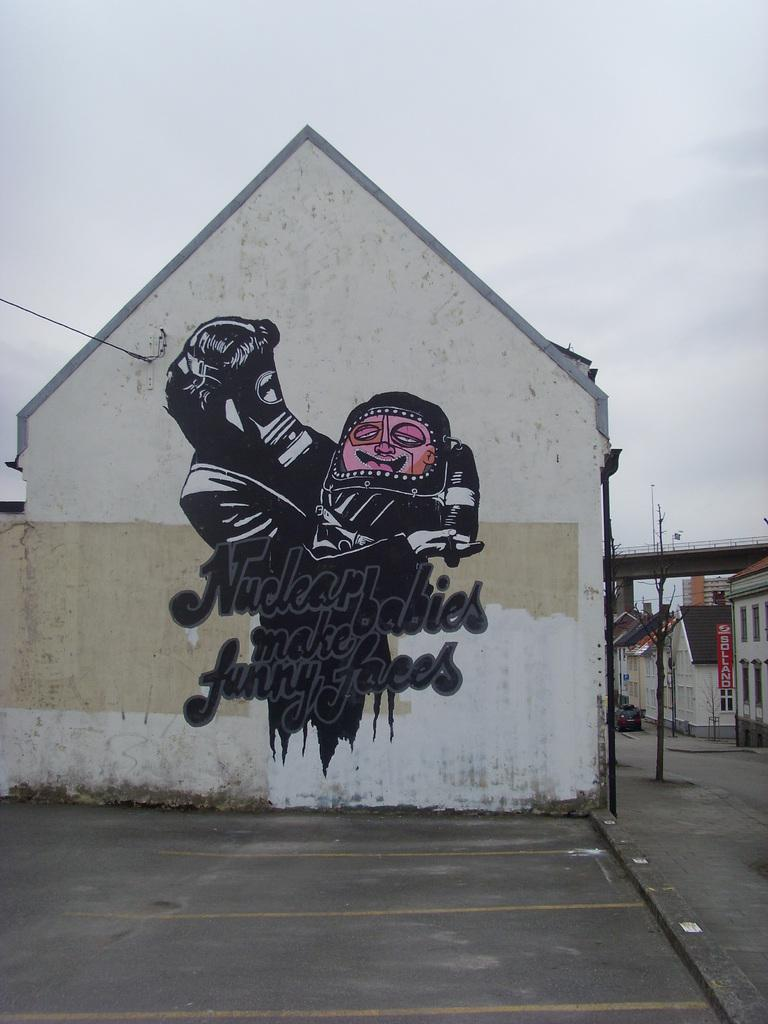<image>
Give a short and clear explanation of the subsequent image. A work of graffiti art on a wall reads Nuclear babies make funny faces. 